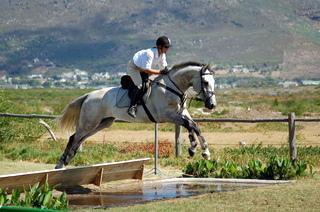How many donuts are on the plate?
Give a very brief answer. 0. 